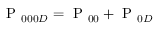<formula> <loc_0><loc_0><loc_500><loc_500>P _ { 0 0 0 D } = P _ { 0 0 } + P _ { 0 D }</formula> 